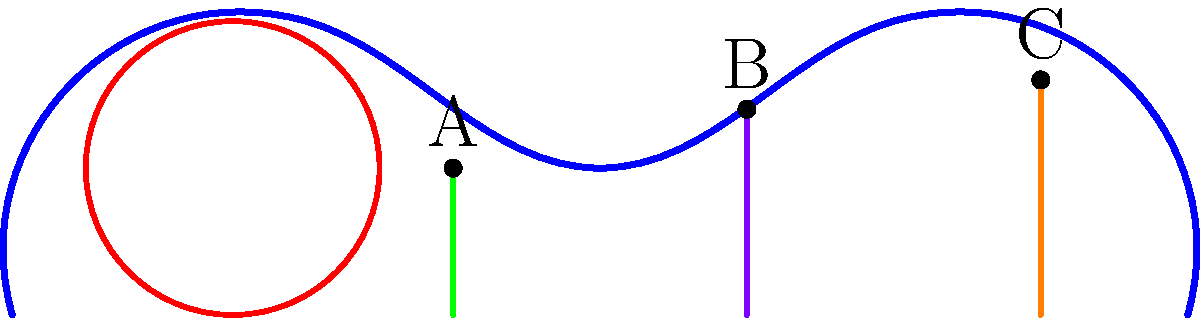In the cross-sectional diagram of the female pelvic floor, structures A, B, and C represent key anatomical components. Based on their relative positions and your expertise in obstetrics and gynecology, identify these structures and explain their clinical significance in maintaining pelvic floor integrity. To identify the structures and explain their clinical significance, let's analyze the diagram step-by-step:

1. Structure A:
   - Located most anteriorly (towards the front)
   - Appears as a tube-like structure
   - This represents the urethra

2. Structure B:
   - Located in the middle of the three structures
   - Appears as a larger tube-like structure
   - This represents the vagina

3. Structure C:
   - Located most posteriorly (towards the back)
   - Appears as a tube-like structure
   - This represents the rectum

Clinical significance:

1. Urethra (A):
   - Crucial for urinary continence
   - Supported by surrounding pelvic floor muscles
   - Weakening of support can lead to stress urinary incontinence

2. Vagina (B):
   - Important for sexual function and childbirth
   - Supported by pelvic floor muscles and connective tissue
   - Weakening can lead to pelvic organ prolapse

3. Rectum (C):
   - Essential for fecal continence
   - Supported by pelvic floor muscles and anal sphincters
   - Weakening can lead to fecal incontinence or rectal prolapse

The pelvic floor muscles (depicted by the curved blue line) provide crucial support to all three structures. Maintaining the integrity of these muscles through proper assessment, education, and rehabilitation is essential for preventing and managing pelvic floor disorders.
Answer: A: Urethra, B: Vagina, C: Rectum; clinical significance: urinary continence, sexual function/childbirth, and fecal continence, respectively. 